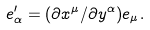Convert formula to latex. <formula><loc_0><loc_0><loc_500><loc_500>e ^ { \prime } _ { \alpha } = ( \partial x ^ { \mu } / \partial y ^ { \alpha } ) e _ { \mu } .</formula> 